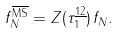<formula> <loc_0><loc_0><loc_500><loc_500>f _ { N } ^ { \overline { \text {MS} } } & = Z ( \tau ^ { \underline { 1 2 } } _ { 1 } ) \, f _ { N } .</formula> 